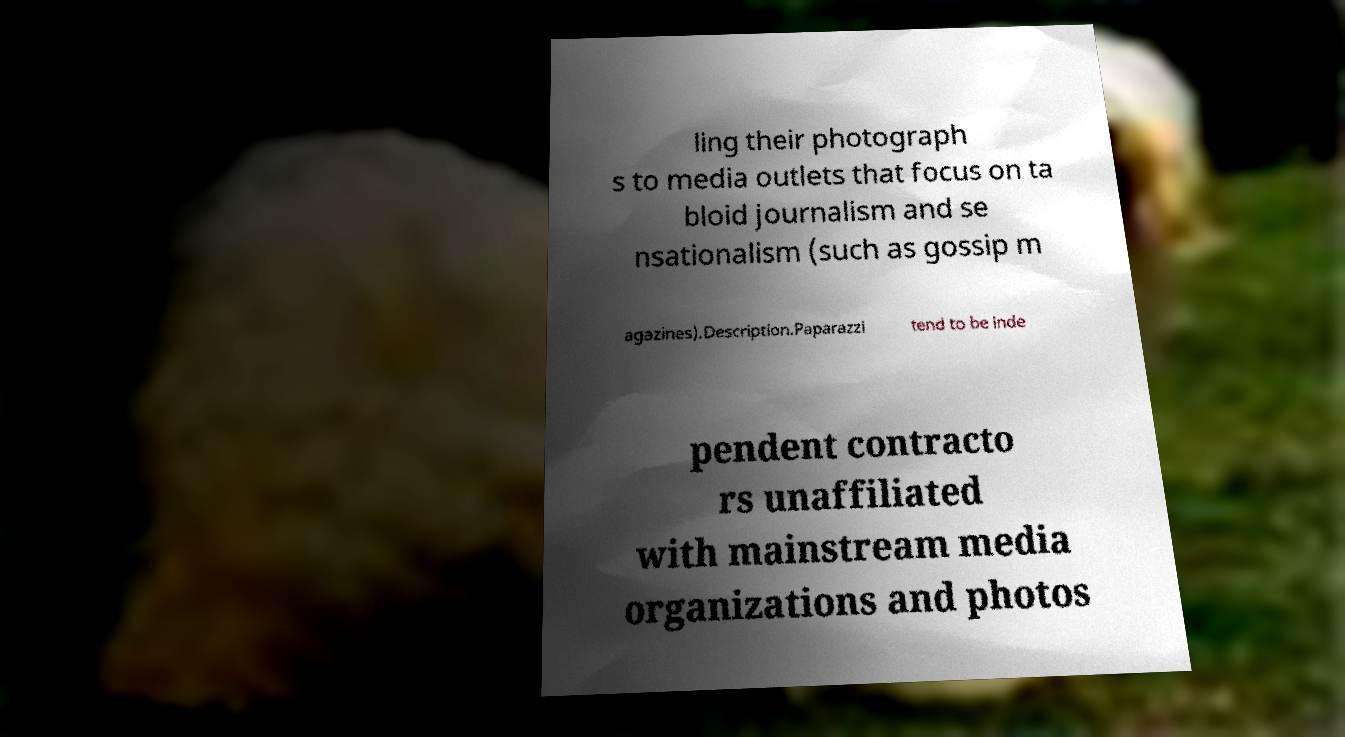Can you read and provide the text displayed in the image?This photo seems to have some interesting text. Can you extract and type it out for me? ling their photograph s to media outlets that focus on ta bloid journalism and se nsationalism (such as gossip m agazines).Description.Paparazzi tend to be inde pendent contracto rs unaffiliated with mainstream media organizations and photos 